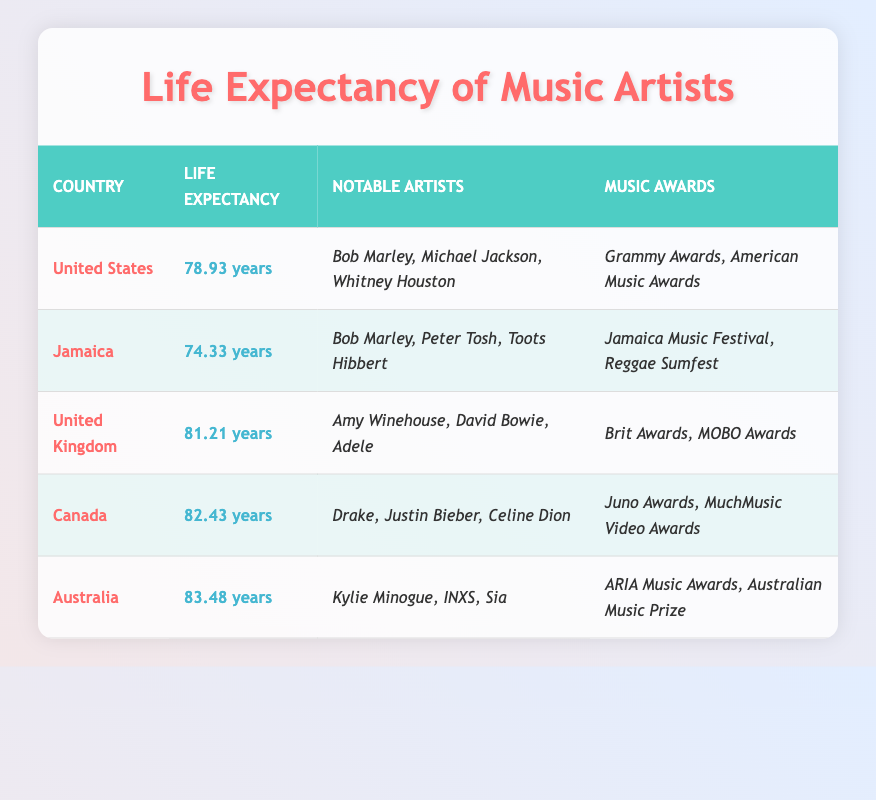What is the average life expectancy of artists from Jamaica? The average life expectancy of artists from Jamaica is presented in the table. It states that the Average Life Expectancy for Jamaica is 74.33 years.
Answer: 74.33 years Which country has the highest average life expectancy for artists? By comparing the values of average life expectancy across the listed countries, Australia has the highest average life expectancy at 83.48 years.
Answer: Australia Do artists from the United States receive more types of music awards than those from Jamaica? The table shows that artists from the United States participate in two types of music awards (Grammy Awards and American Music Awards), whereas artists from Jamaica participate in two as well (Jamaica Music Festival and Reggae Sumfest). Therefore, both countries have the same number of music awards.
Answer: No What is the difference in average life expectancy between artists from Canada and those from the United Kingdom? The average life expectancy for Canada is 82.43 years and for the United Kingdom, it is 81.21 years. To find the difference, subtract 81.21 from 82.43, which gives 1.22 years.
Answer: 1.22 years Are there any notable artists from Jamaica listed in this table? The table specifies that notable artists from Jamaica include Bob Marley, Peter Tosh, and Toots Hibbert, confirming the presence of notable artists from Jamaica.
Answer: Yes How many average years of life expectancy do artists from Australia exceed those from Jamaica? The average life expectancy for artists from Australia is 83.48 years and for Jamaica, it is 74.33 years. To find how many years Australia's average exceeds Jamaica's, subtract 74.33 from 83.48, resulting in a difference of 9.15 years.
Answer: 9.15 years Which country has the same average life expectancy as Jamaican artists? A quick review of the table reveals that no other country has a life expectancy of 74.33 years. The closest values are the United States and the United Kingdom, which have higher life expectancies.
Answer: None What is the total number of notable artists listed for artists from Canada and the United Kingdom combined? From the table, Canada has three notable artists (Drake, Justin Bieber, Celine Dion) and the United Kingdom also lists three (Amy Winehouse, David Bowie, Adele). Therefore, combining both gives a total of 3 + 3 = 6 notable artists.
Answer: 6 